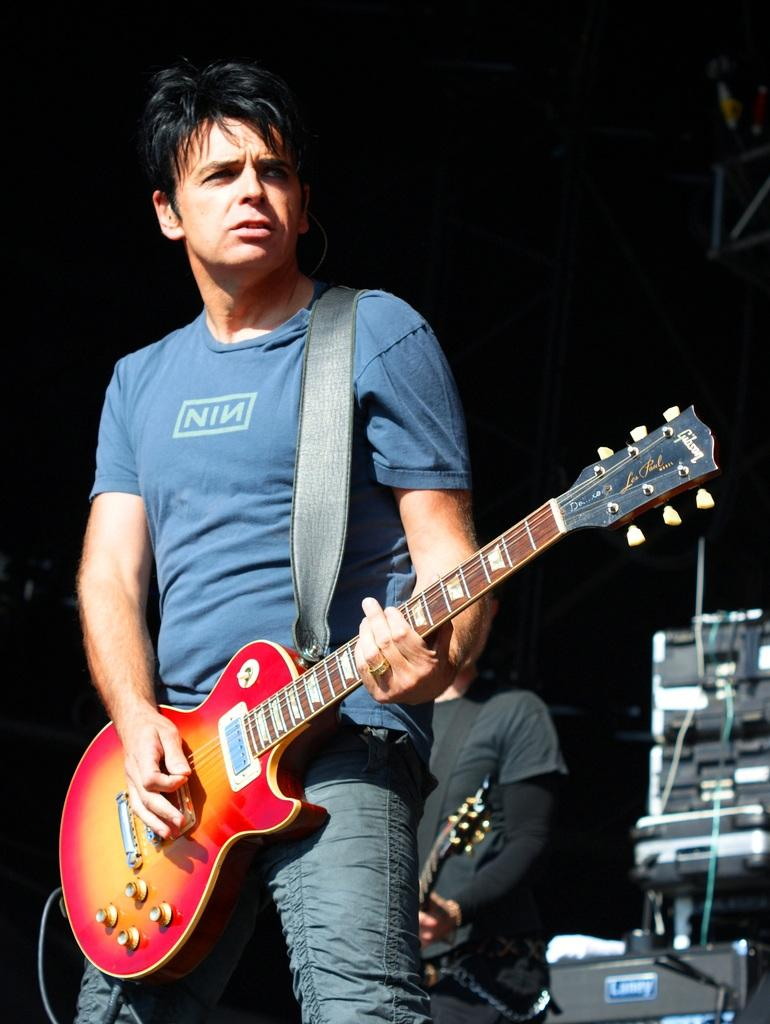What is the main activity of the person in the image? The person in the image is holding a guitar and playing it. Can you describe the second person in the image? The second person in the image is also playing a guitar. What are the two people doing together in the image? Both people are playing guitars, suggesting they might be performing or practicing together. What type of pen is the person using to write music in the image? There is no pen or music writing activity visible in the image; the person is playing a guitar. 